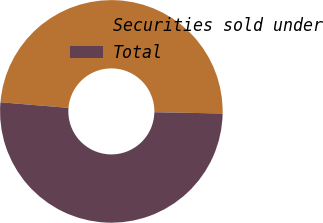Convert chart to OTSL. <chart><loc_0><loc_0><loc_500><loc_500><pie_chart><fcel>Securities sold under<fcel>Total<nl><fcel>48.99%<fcel>51.01%<nl></chart> 